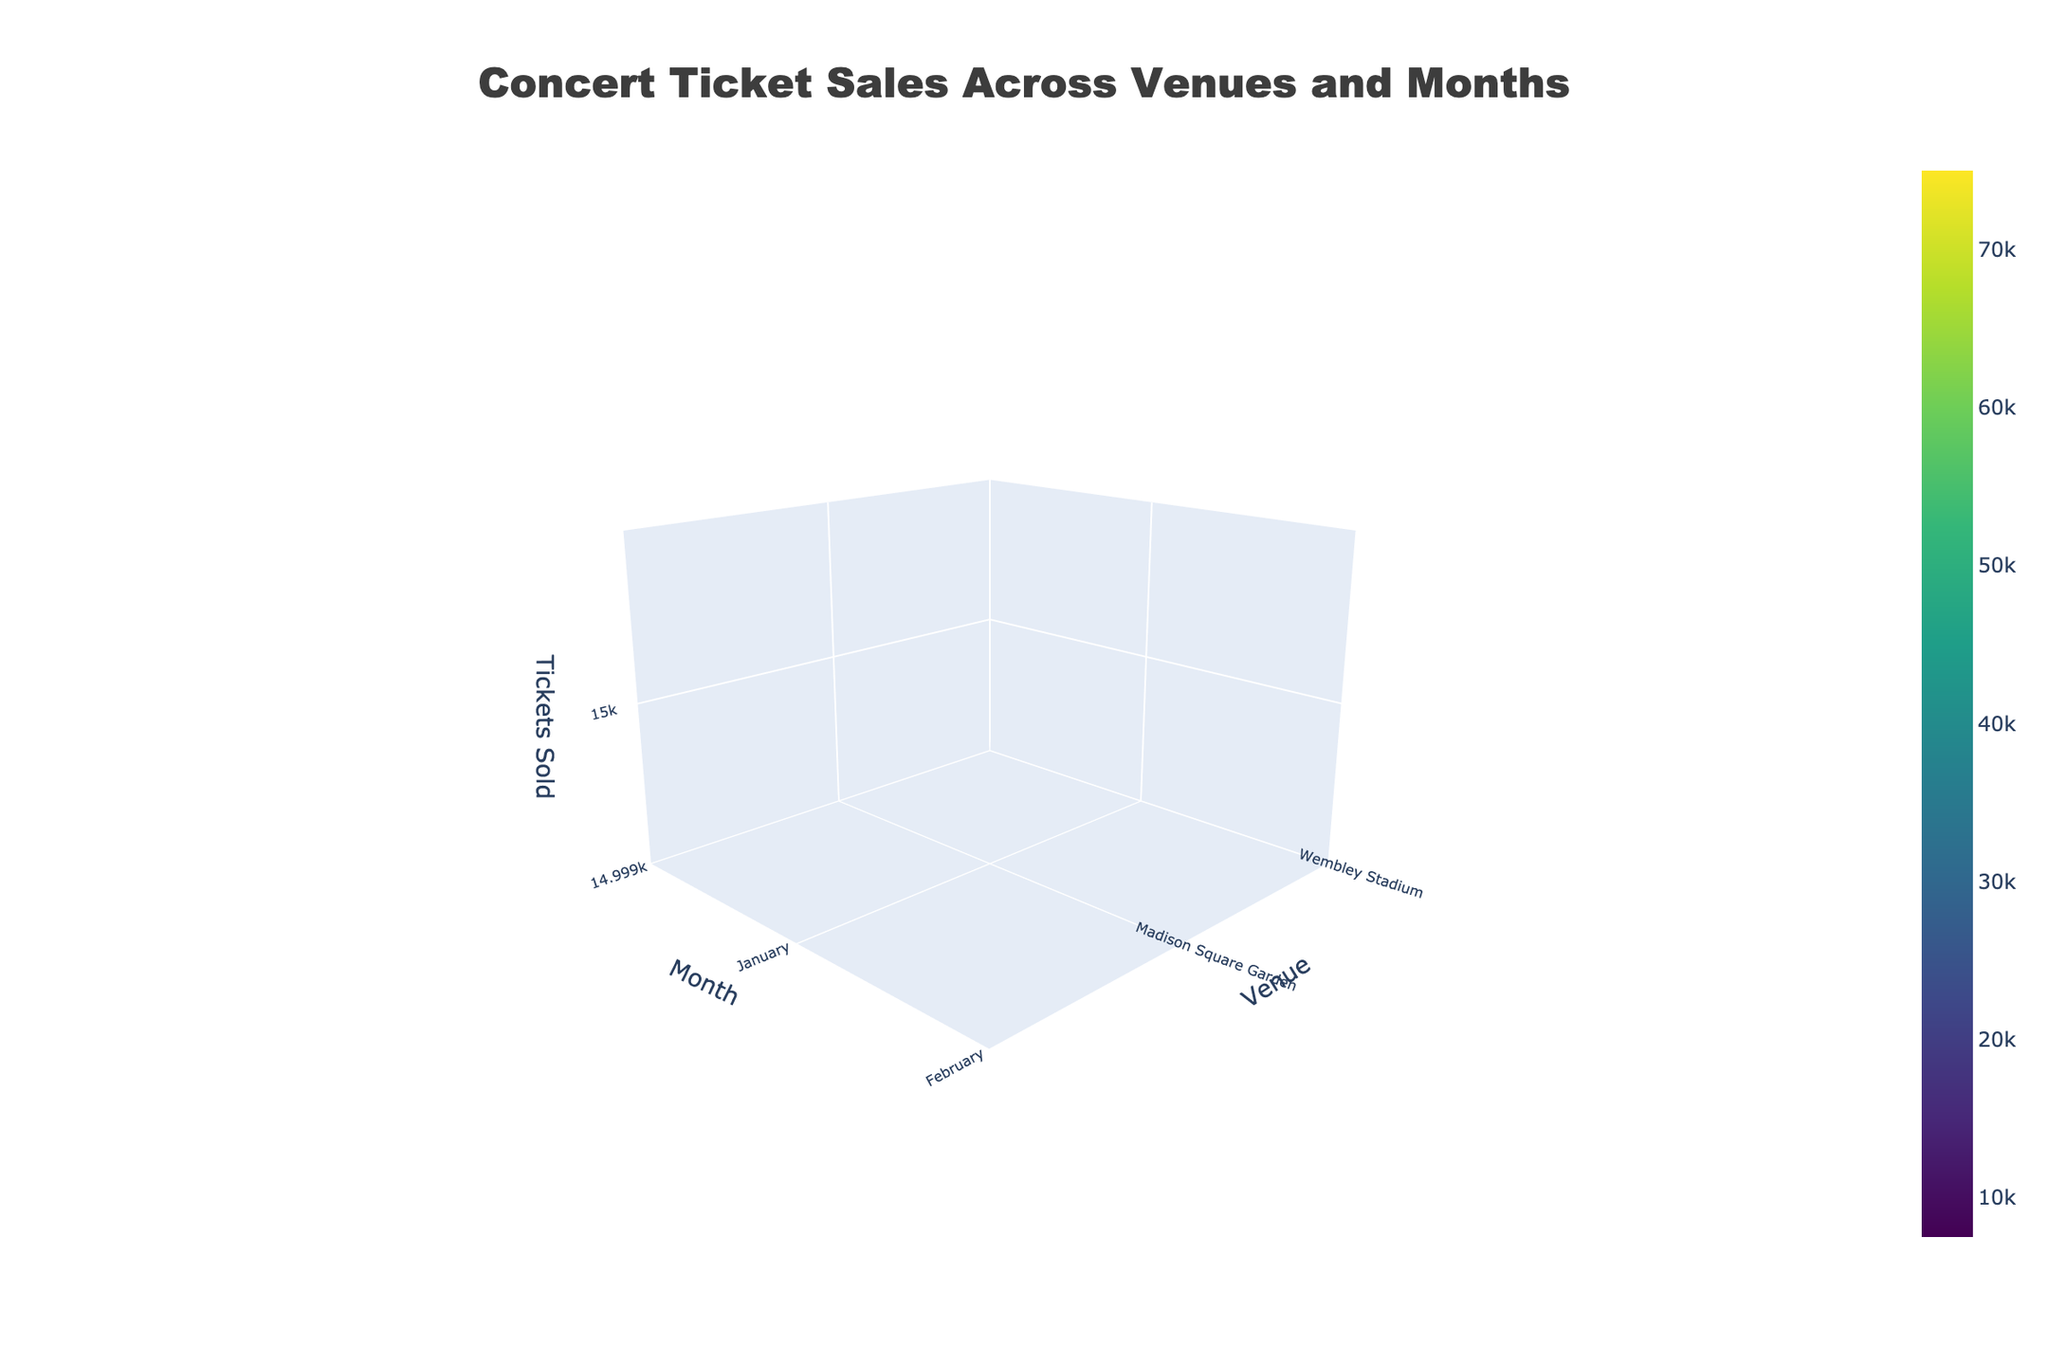What is the title of the figure? The title is generally displayed at the top of the figure. In this case, it is specified in the code to be "Concert Ticket Sales Across Venues and Months". You can directly read it from the title of the figure.
Answer: "Concert Ticket Sales Across Venues and Months" On which axis do the venue names appear? The venue names correspond to the categorical variable "Venue" and are plotted on the y-axis, which is the vertical axis in the 3D surface plot.
Answer: y-axis Which month had the highest ticket sales at Wembley Stadium? To find this, you look at the z-axis values for each month at Wembley Stadium. The highest z-axis value, which corresponds to ticket sales, occurs in August.
Answer: August Compare the ticket sales in January at Madison Square Garden and O2 Arena. Which one sold more tickets and by how much? To compare ticket sales, look at the z-axis values for both venues in January. Madison Square Garden sold 15,000 tickets and O2 Arena sold 18,000 tickets. The difference is 18,000 - 15,000 = 3,000 tickets.
Answer: O2 Arena, 3,000 tickets What is the average number of tickets sold at Red Rocks Amphitheatre throughout the year? Calculate the mean by summing up the ticket sales for each month at Red Rocks Amphitheatre and then dividing by the number of months where sales data is provided. (8000 + 9500 + 9000 + 7500) / 4 = 10,000 tickets / 4 months = 9,000 tickets.
Answer: 9,000 tickets Which venue had the steepest increase in ticket sales from one month to another? Determine the month-to-month differences in z-axis values for each venue and identify which venue had the largest difference. Comparing all venues, the steepest increase is at Wembley Stadium from February (65,000) to May (70,000) with a 5,000 ticket increase.
Answer: Wembley Stadium Which venue had the most consistent ticket sales throughout the year? Consistency can be interpreted as having the smallest variation in ticket sales. By examining z-axis values for each venue, Hollywood Bowl had relatively close sales figures (16000, 17500, 18000, 16500) suggesting a more consistent pattern.
Answer: Hollywood Bowl What is the combined ticket sales for O2 Arena in April and Madison Square Garden in July? Sum the ticket sales for these two data points: O2 Arena in April (20,000) and Madison Square Garden in July (20,000). Total = 20,000 + 20,000 = 40,000 tickets.
Answer: 40,000 tickets Which venue had the lowest ticket sales in December? Looking at the z-axis values for December, Red Rocks Amphitheatre has the lowest ticket sales with 7,500 tickets sold.
Answer: Red Rocks Amphitheatre 